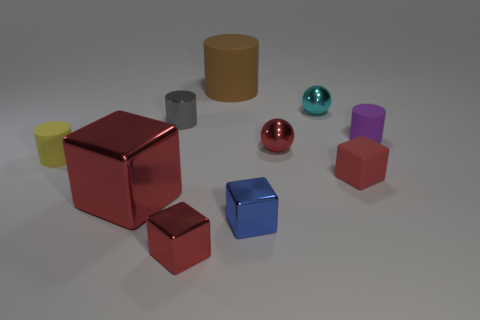There is another large thing that is the same shape as the blue metal thing; what is its material?
Provide a short and direct response. Metal. What material is the tiny cyan ball?
Keep it short and to the point. Metal. What material is the tiny red object left of the small sphere in front of the matte cylinder to the right of the cyan object?
Keep it short and to the point. Metal. How many things are green metal cylinders or tiny shiny balls?
Provide a succinct answer. 2. There is a rubber cylinder that is right of the large red object and on the left side of the cyan ball; how big is it?
Give a very brief answer. Large. Is the number of big red metal objects behind the purple matte thing less than the number of yellow cylinders?
Provide a short and direct response. Yes. What is the shape of the blue thing that is the same material as the large cube?
Your answer should be compact. Cube. There is a tiny red thing that is behind the small yellow matte cylinder; is its shape the same as the matte object that is left of the tiny gray cylinder?
Make the answer very short. No. Is the number of small purple matte cylinders left of the purple rubber thing less than the number of small metallic cylinders that are behind the small blue metallic block?
Offer a terse response. Yes. The large thing that is the same color as the matte block is what shape?
Ensure brevity in your answer.  Cube. 